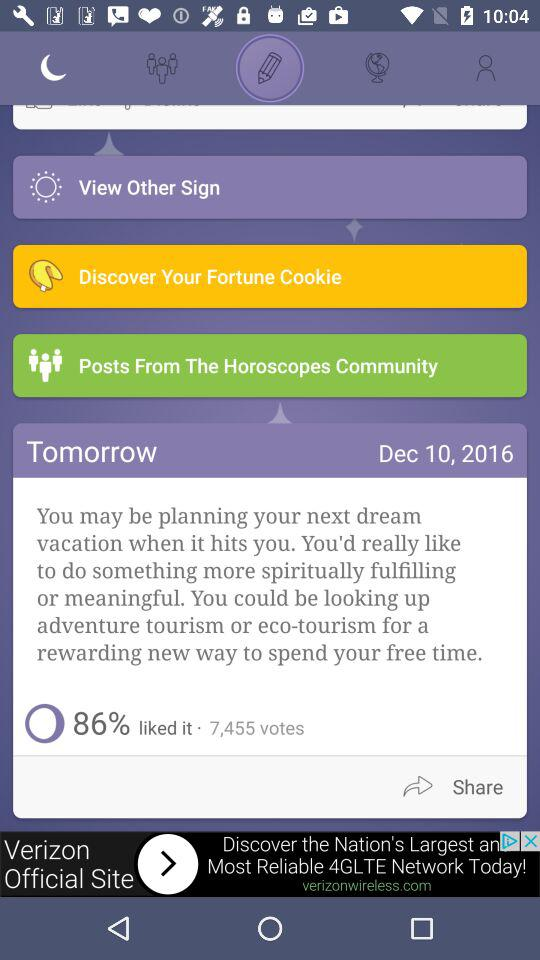How many total votes are there? There are a total of 7,455 votes. 